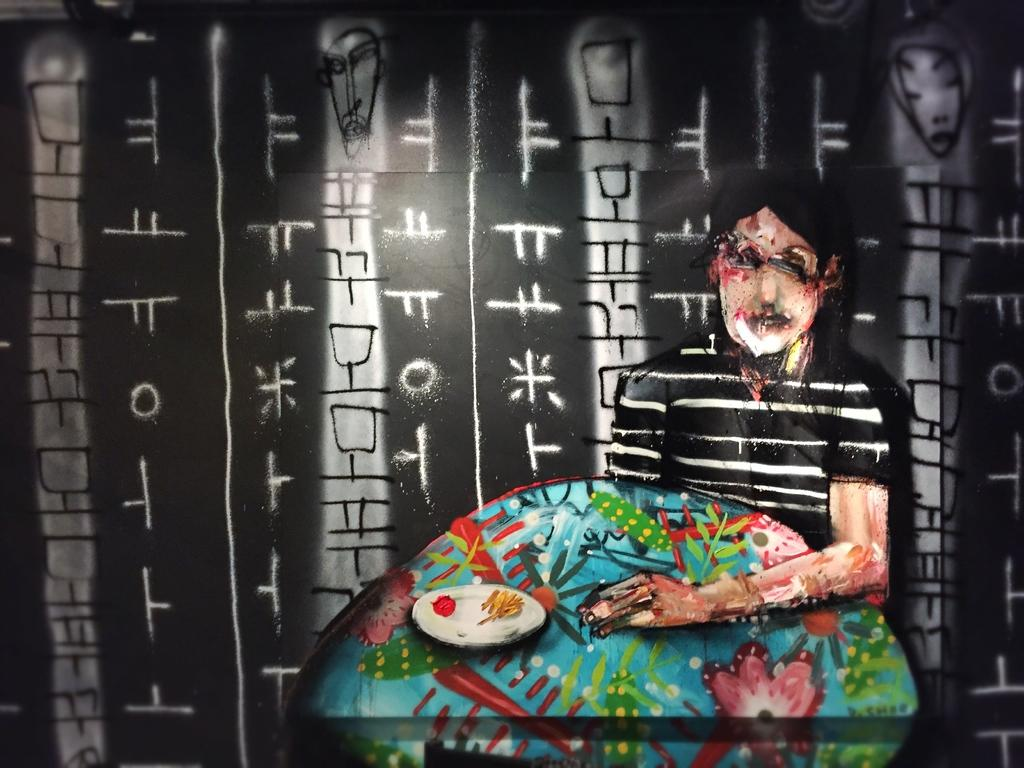What can be seen in the image? There is a person in the image. What is the person holding? The person is holding an object. Can you describe the glass in the image? The glass has letters and a drawing on it. What type of bells can be heard ringing in the image? There are no bells present in the image, and therefore no sound can be heard. What type of thread is being used to calculate the measurements in the image? There is no thread or calculator present in the image. 